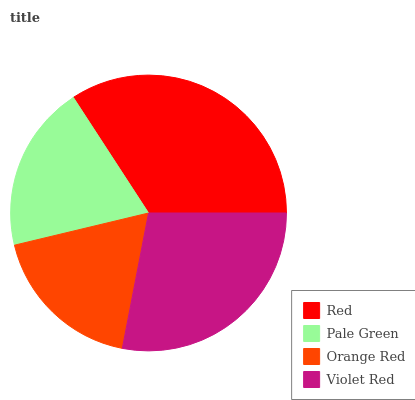Is Orange Red the minimum?
Answer yes or no. Yes. Is Red the maximum?
Answer yes or no. Yes. Is Pale Green the minimum?
Answer yes or no. No. Is Pale Green the maximum?
Answer yes or no. No. Is Red greater than Pale Green?
Answer yes or no. Yes. Is Pale Green less than Red?
Answer yes or no. Yes. Is Pale Green greater than Red?
Answer yes or no. No. Is Red less than Pale Green?
Answer yes or no. No. Is Violet Red the high median?
Answer yes or no. Yes. Is Pale Green the low median?
Answer yes or no. Yes. Is Pale Green the high median?
Answer yes or no. No. Is Red the low median?
Answer yes or no. No. 